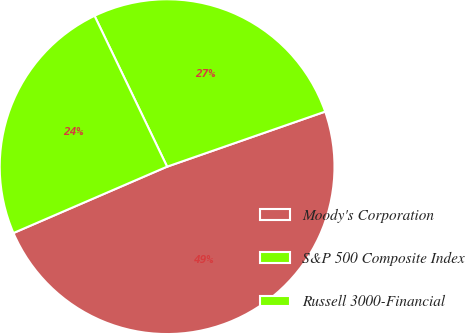Convert chart to OTSL. <chart><loc_0><loc_0><loc_500><loc_500><pie_chart><fcel>Moody's Corporation<fcel>S&P 500 Composite Index<fcel>Russell 3000-Financial<nl><fcel>48.84%<fcel>26.8%<fcel>24.35%<nl></chart> 